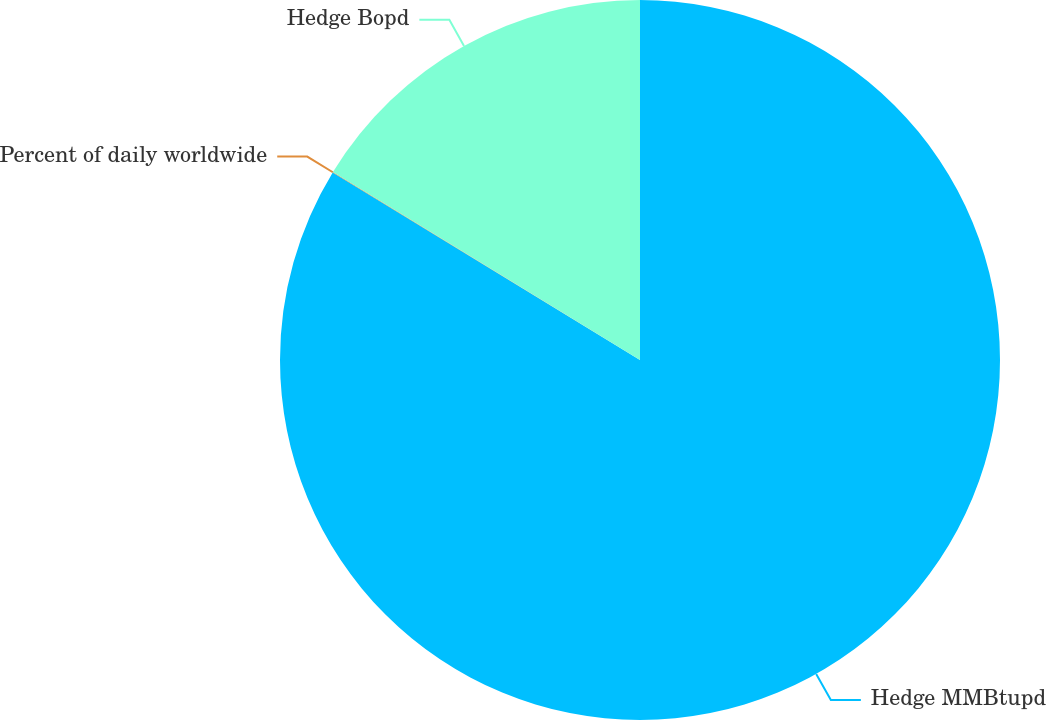Convert chart to OTSL. <chart><loc_0><loc_0><loc_500><loc_500><pie_chart><fcel>Hedge MMBtupd<fcel>Percent of daily worldwide<fcel>Hedge Bopd<nl><fcel>83.73%<fcel>0.02%<fcel>16.26%<nl></chart> 